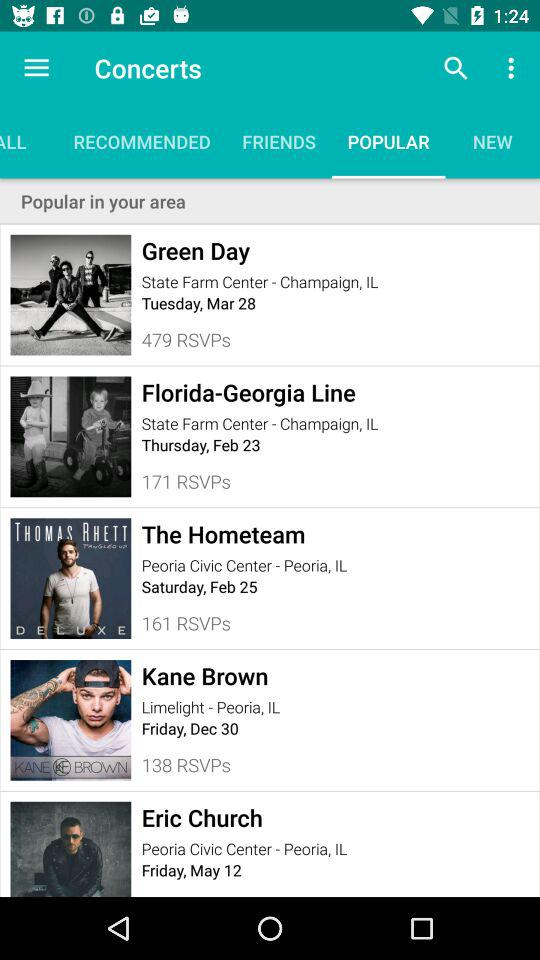What is the date of "The Hometeam" concert? The date of "The Hometeam" concert is Saturday, February 25. 